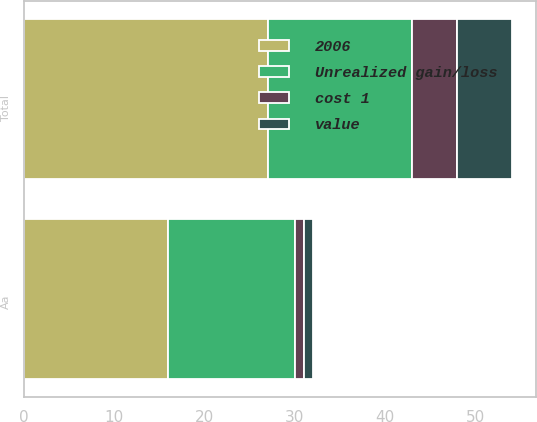<chart> <loc_0><loc_0><loc_500><loc_500><stacked_bar_chart><ecel><fcel>Aa<fcel>Total<nl><fcel>cost 1<fcel>1<fcel>5<nl><fcel>Unrealized gain/loss<fcel>14<fcel>16<nl><fcel>value<fcel>1<fcel>6<nl><fcel>2006<fcel>16<fcel>27<nl></chart> 